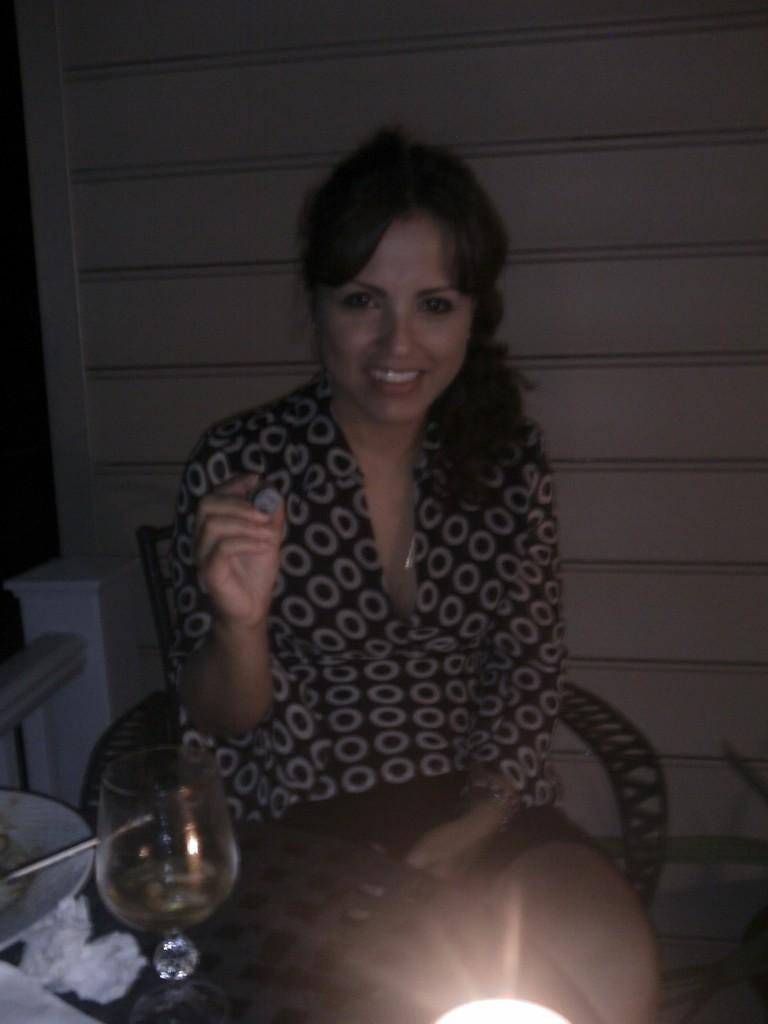Who is present in the image? There is a woman in the image. What is the woman doing in the image? The woman is sitting on a chair. What objects are on the table in front of the woman? There is a glass and a plate on the table. What can be seen in the background of the image? There is a wall in the background of the image. What type of snail can be seen crawling on the woman's shoulder in the image? There is no snail present in the image; the woman is sitting on a chair with no snail visible. 